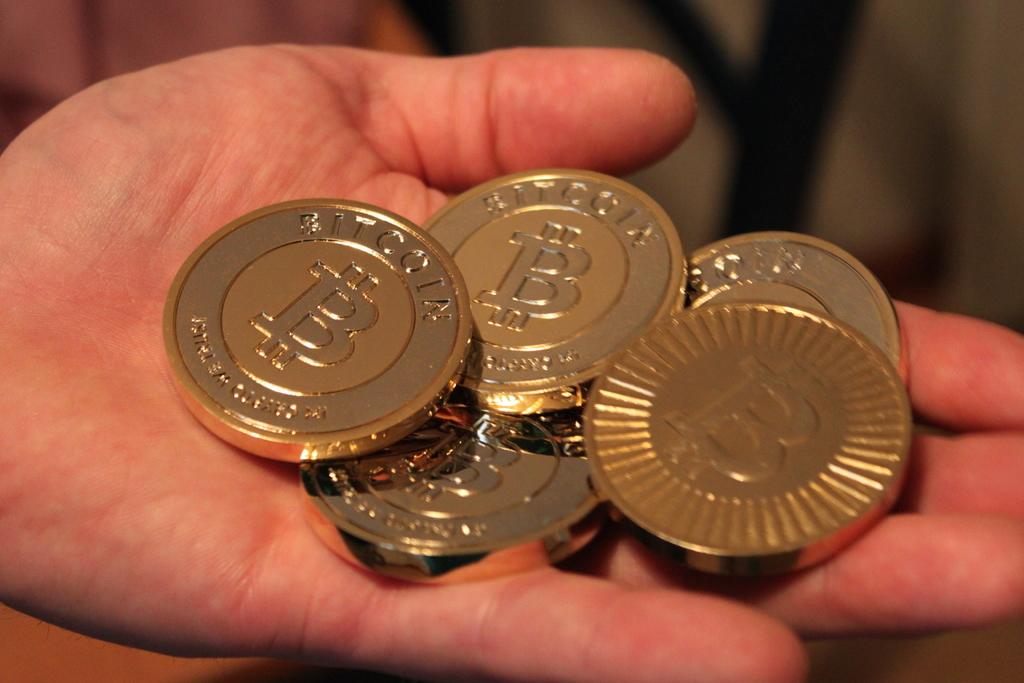<image>
Offer a succinct explanation of the picture presented. A person holds a number of Bitcoin gold coins in the palm of their hand. 